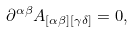Convert formula to latex. <formula><loc_0><loc_0><loc_500><loc_500>\partial ^ { \alpha \beta } A _ { [ \alpha \beta ] [ \gamma \delta ] } = 0 ,</formula> 